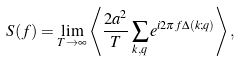Convert formula to latex. <formula><loc_0><loc_0><loc_500><loc_500>S ( f ) = \lim _ { T \rightarrow \infty } \left \langle \frac { 2 a ^ { 2 } } { T } \sum _ { k , q } e ^ { i 2 \pi f \Delta ( k ; q ) } \right \rangle ,</formula> 